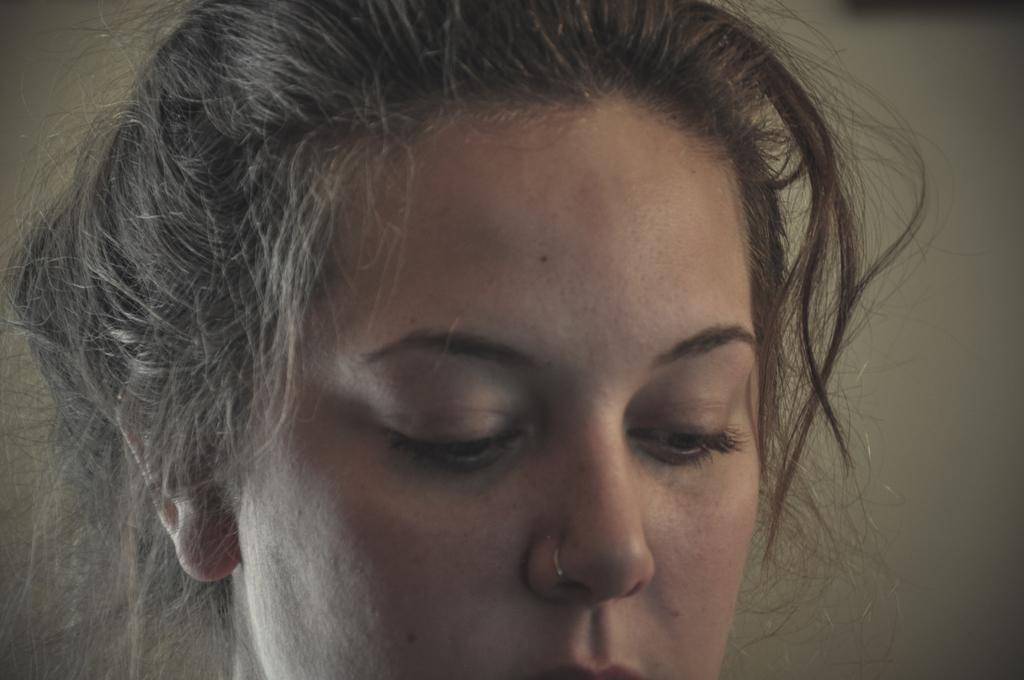Who is present in the image? There are women in the image. What can be seen in the background of the image? There is a cream-colored wall in the background of the image. What type of soup is being served in the image? There is no soup present in the image; it features women and a cream-colored wall in the background. How long has the rock been in the image? There is no rock present in the image. 